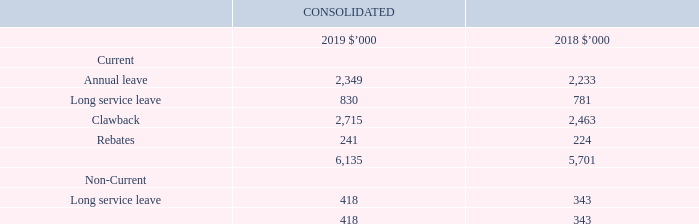3.6 Provisions
Recognition, measurement and classification
Employee benefits – annual and long service leave
The Group recognises a liability for long service leave and annual leave measured as the present value of expected future payments to be made in respect of services provided by employees up to the reporting date using the projected unit credit method. Consideration is given to expected future wage and salary levels, experience of employee departures, and periods of service. Expected future payments are discounted using market yields at the reporting date on corporate bond rates with terms to maturity and currencies that match, as closely as possible, the estimated future cash outflows.
The Group does not expect its long service leave or annual leave benefits to be settled wholly within 12 months of the reporting date.
Annual and long service leave are classified as current where there is a current obligation to pay the employee shall they leave the Group.
Clawback provisions
Upfront fees received from certain insurance funds, broadband providers and mortgage brokers can be clawed back in the event of early termination of membership. They vary across the industries and are usually triggered where a referred member terminates their policy. Each relevant Product Provider has an individual agreement and the clawback period ranges between 0 and 24 months, depending on the agreement.
Key estimates - Employee benefits
Provisions are measured at the present value of management’s best estimate of the expenditure required to settle the present obligation at the reporting date using the discounted cash flow methodology. The risks specific to the provision are factored into the cash flows and as such a corporate bond rate relative to the expected life of the provision is used as a discount rate. If the effect of the time value of money is material, provisions are discounted using a current pre-tax rate that reflects the time value of money and the risks specific to the liability. The increase in the provision resulting from the passage of time is recognised as interest expense.
Key estimates - Clawback provisions
The Group provides for this liability based upon historic average rates of attrition and recognises revenue net of these clawback amounts.
How are provisions measured? At the present value of management’s best estimate of the expenditure required to settle the present obligation at the reporting date using the discounted cash flow methodology. What is the range of the clawback period? Between 0 and 24 months. How is annual and long service leave classified? Classified as current where there is a current obligation to pay the employee shall they leave the group. What is the percentage change in the annual leave provisions from 2018 to 2019?
Answer scale should be: percent. (2,349-2,233)/2,233
Answer: 5.19. What is the percentage change in the current provisions from 2018 to 2019?
Answer scale should be: percent. (6,135-5,701)/5,701
Answer: 7.61. What is the percentage change in the non-current provisions from 2018 to 2019?
Answer scale should be: percent. (418-343)/343
Answer: 21.87. 